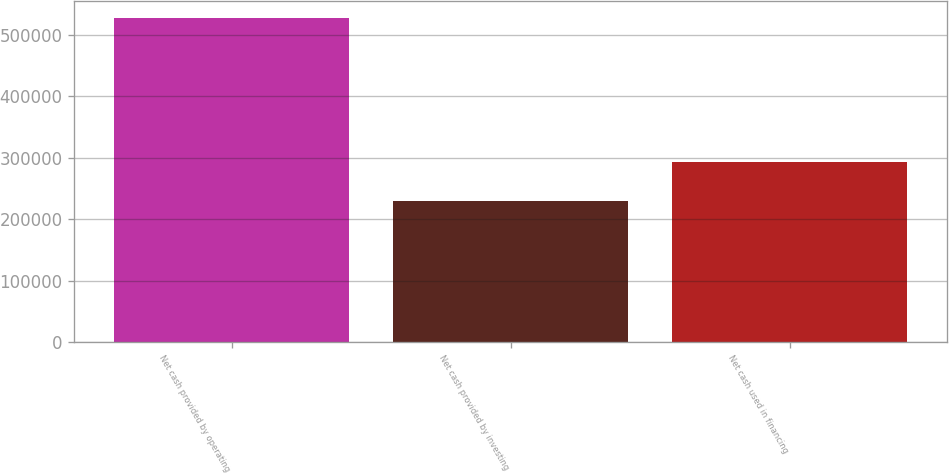Convert chart. <chart><loc_0><loc_0><loc_500><loc_500><bar_chart><fcel>Net cash provided by operating<fcel>Net cash provided by investing<fcel>Net cash used in financing<nl><fcel>527979<fcel>229756<fcel>293443<nl></chart> 